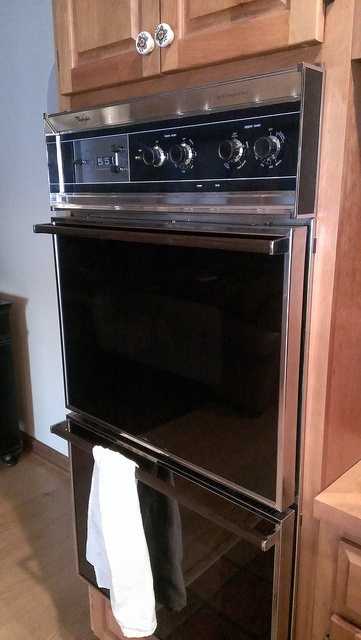Describe the objects in this image and their specific colors. I can see a oven in darkgray, black, gray, and white tones in this image. 